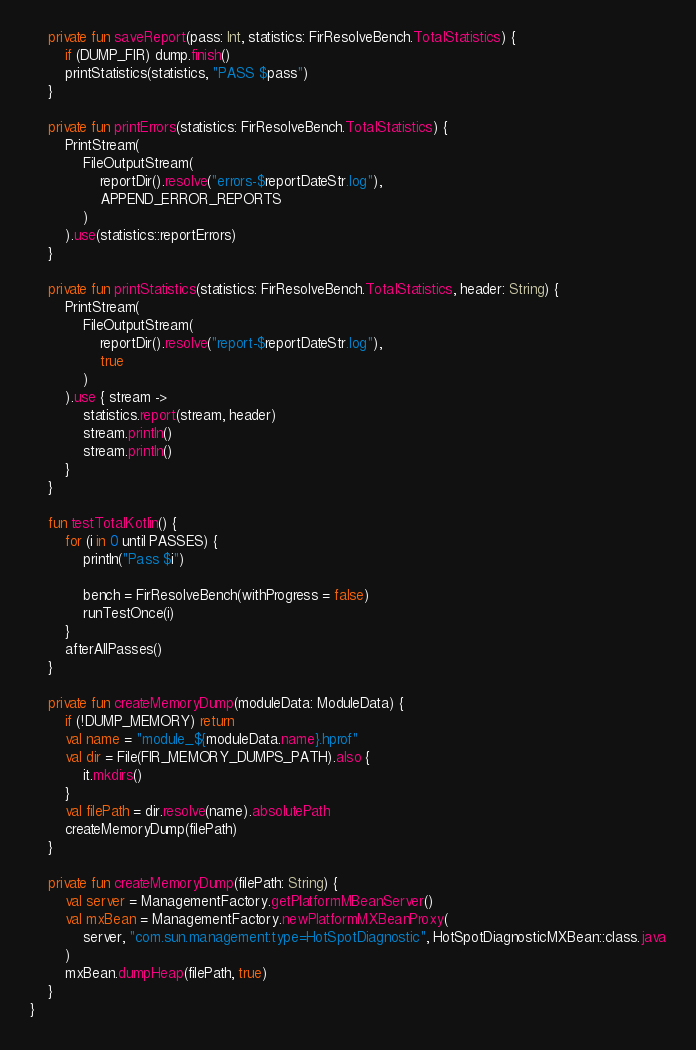Convert code to text. <code><loc_0><loc_0><loc_500><loc_500><_Kotlin_>
    private fun saveReport(pass: Int, statistics: FirResolveBench.TotalStatistics) {
        if (DUMP_FIR) dump.finish()
        printStatistics(statistics, "PASS $pass")
    }

    private fun printErrors(statistics: FirResolveBench.TotalStatistics) {
        PrintStream(
            FileOutputStream(
                reportDir().resolve("errors-$reportDateStr.log"),
                APPEND_ERROR_REPORTS
            )
        ).use(statistics::reportErrors)
    }

    private fun printStatistics(statistics: FirResolveBench.TotalStatistics, header: String) {
        PrintStream(
            FileOutputStream(
                reportDir().resolve("report-$reportDateStr.log"),
                true
            )
        ).use { stream ->
            statistics.report(stream, header)
            stream.println()
            stream.println()
        }
    }

    fun testTotalKotlin() {
        for (i in 0 until PASSES) {
            println("Pass $i")

            bench = FirResolveBench(withProgress = false)
            runTestOnce(i)
        }
        afterAllPasses()
    }

    private fun createMemoryDump(moduleData: ModuleData) {
        if (!DUMP_MEMORY) return
        val name = "module_${moduleData.name}.hprof"
        val dir = File(FIR_MEMORY_DUMPS_PATH).also {
            it.mkdirs()
        }
        val filePath = dir.resolve(name).absolutePath
        createMemoryDump(filePath)
    }

    private fun createMemoryDump(filePath: String) {
        val server = ManagementFactory.getPlatformMBeanServer()
        val mxBean = ManagementFactory.newPlatformMXBeanProxy(
            server, "com.sun.management:type=HotSpotDiagnostic", HotSpotDiagnosticMXBean::class.java
        )
        mxBean.dumpHeap(filePath, true)
    }
}
</code> 